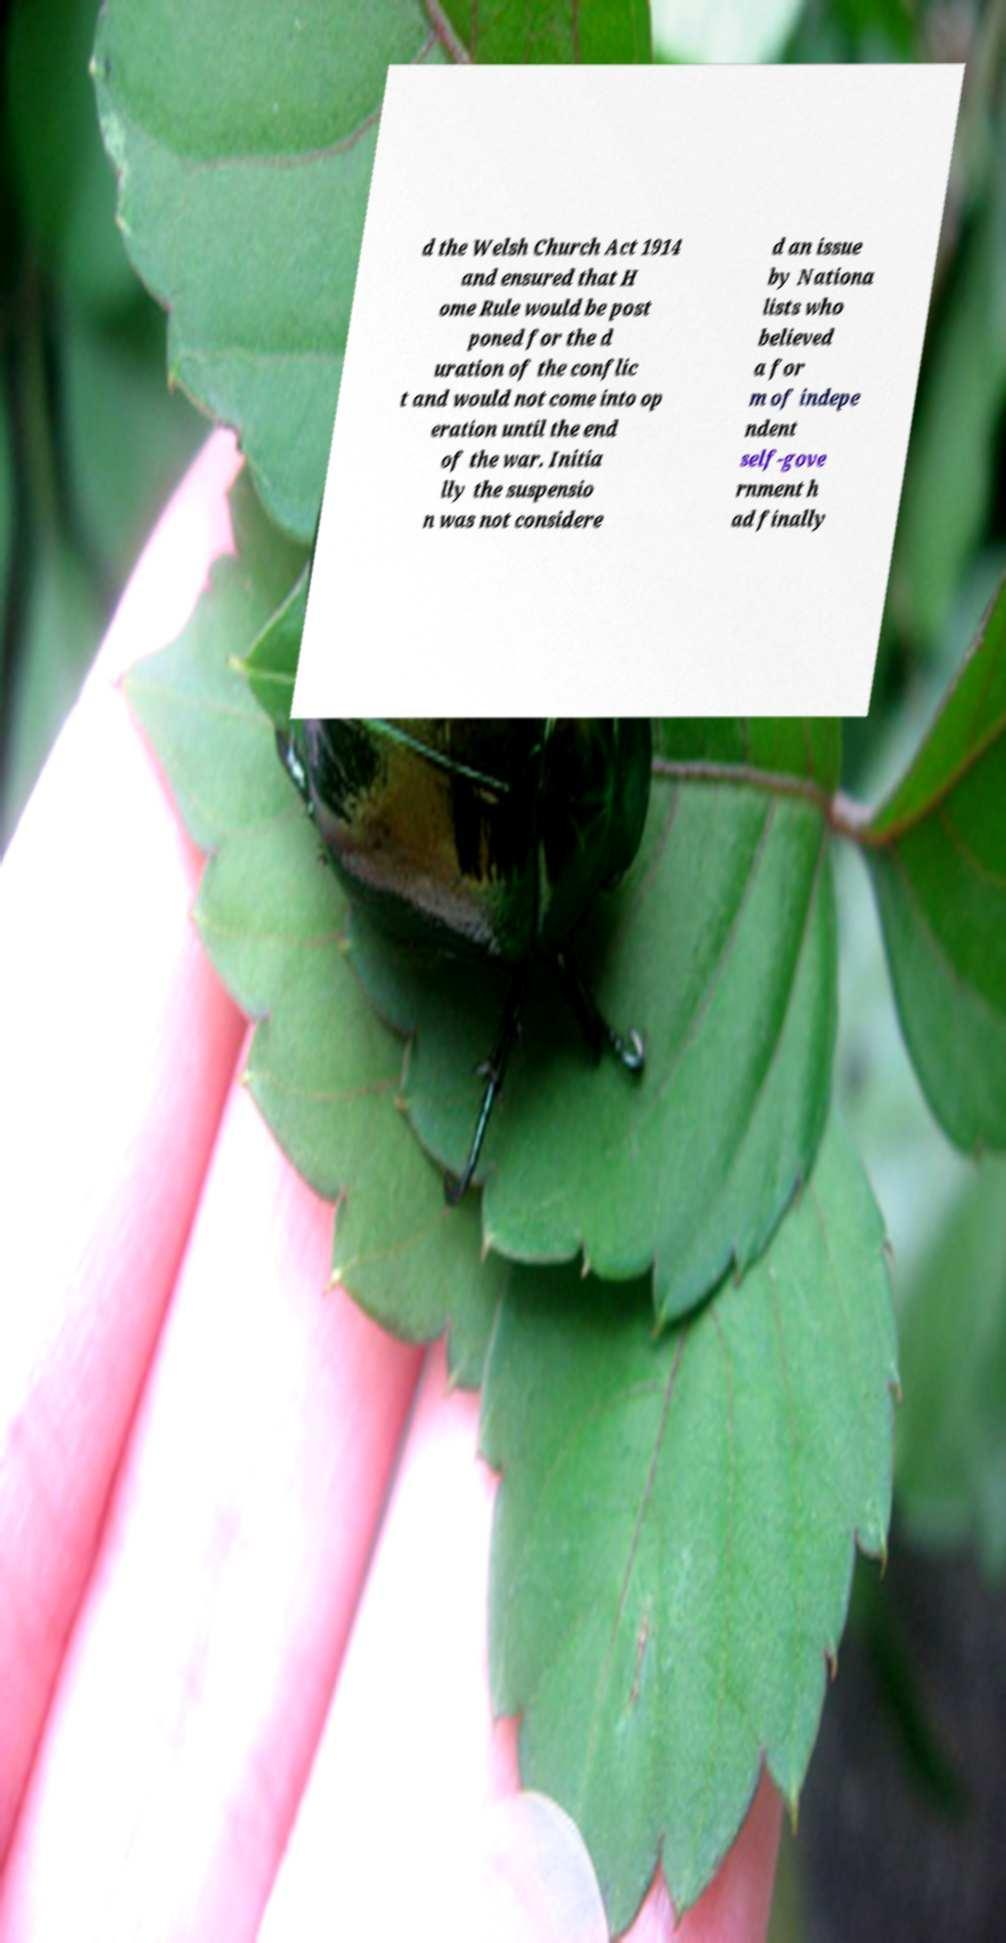Please read and relay the text visible in this image. What does it say? d the Welsh Church Act 1914 and ensured that H ome Rule would be post poned for the d uration of the conflic t and would not come into op eration until the end of the war. Initia lly the suspensio n was not considere d an issue by Nationa lists who believed a for m of indepe ndent self-gove rnment h ad finally 